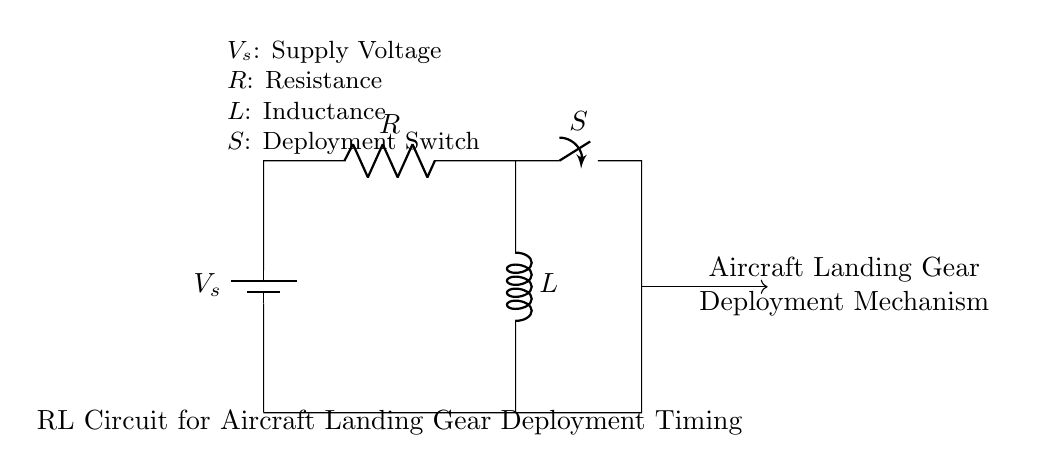What is the supply voltage in this circuit? The circuit indicates a supply voltage represented by V_s, which is typically the voltage required to operate the circuit. The specific value is not shown in the circuit diagram but is indicated as V_s.
Answer: V_s What components are present in the circuit? The circuit includes a battery (V_s), a resistor (R), an inductor (L), and a switch (S). These components are essential for the deployment timing of the aircraft landing gear.
Answer: Battery, Resistor, Inductor, Switch What is the purpose of the switch in this circuit? The switch (S) controls the flow of current to the landing gear deployment mechanism. When closed, it allows the current to flow through the resistor and inductor, influencing the timing for deployment.
Answer: Controls current flow What happens to the current when the switch is closed? When the switch is closed, current begins to flow through the resistor and inductor, and the inductor will resist changes in current, causing a delay in fully reaching the steady state. This influences the timing mechanism of the landing gear deployment.
Answer: Current flows and increases gradually How does the resistance affect the circuit's response time? The resistance (R) in the circuit affects the time constant (τ), which is calculated as τ = L/R. A higher resistance will result in a longer time constant, slowing down the response time of the circuit, and ultimately impacting the deployment timing of the landing gear.
Answer: It increases response time What is the time constant of this RL circuit? The time constant (τ) for an RL circuit is given by the formula τ = L/R. This value indicates the time taken for the current to rise to approximately 63.2% of its maximum value after the switch is closed, which is crucial for timing applications such as landing gear deployment.
Answer: L/R 